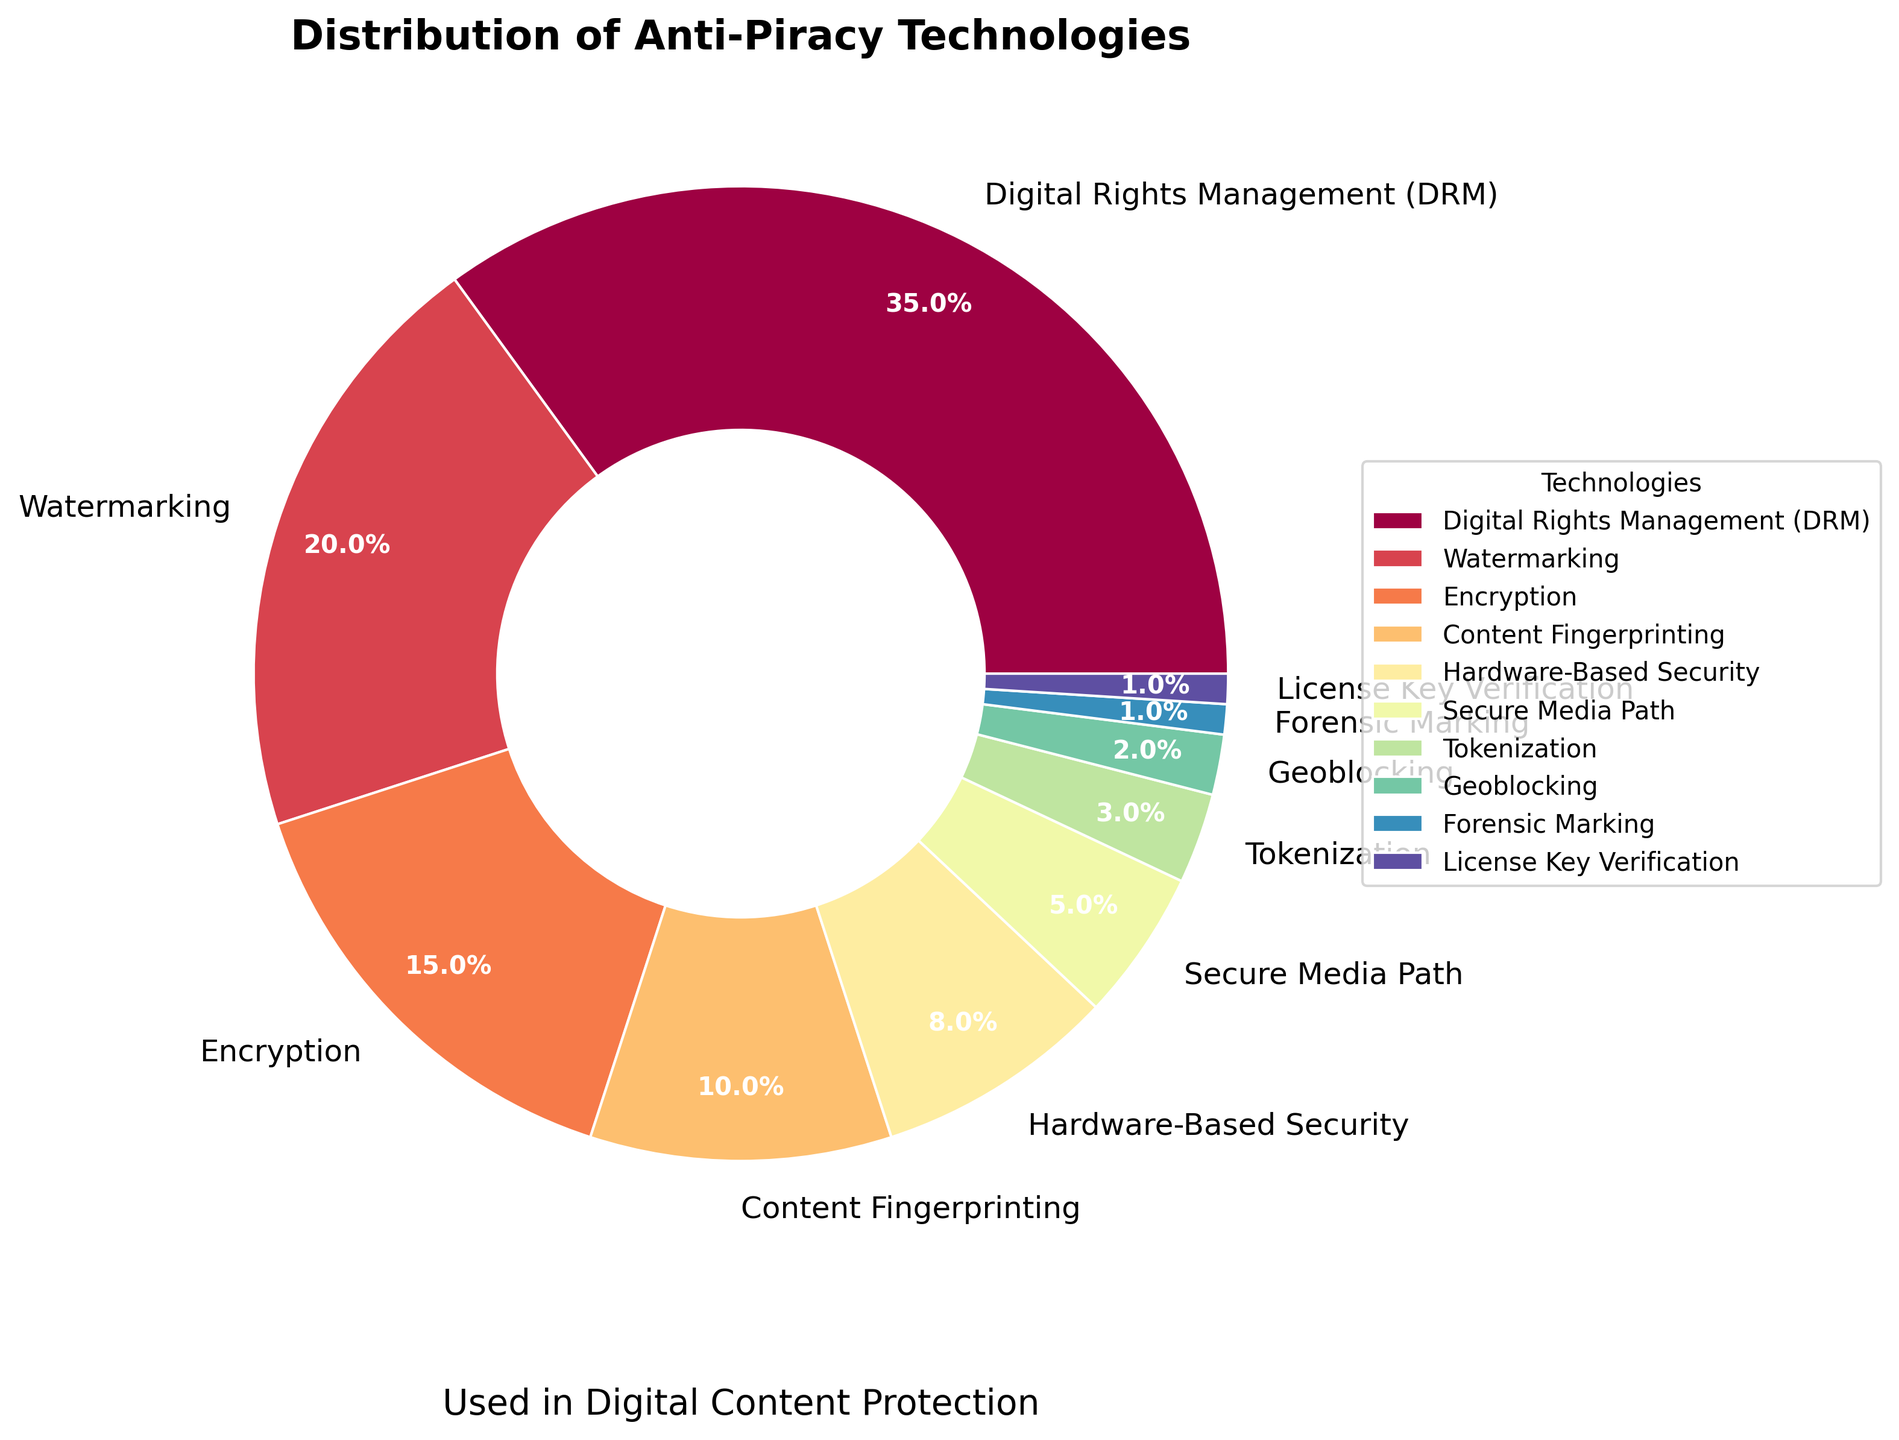What's the largest segment in the pie chart? The segment labeled "Digital Rights Management (DRM)" occupies the largest portion of the pie chart at 35%.
Answer: Digital Rights Management (DRM) Which two technologies have a combined percentage of 50%? The two technologies are "Digital Rights Management (DRM)" with 35% and "Watermarking" with 20%. Adding them gives 35% + 20% = 55%.
Answer: Digital Rights Management (DRM) and Watermarking How does Encryption compare to Content Fingerprinting in terms of percentage? Encryption makes up 15% of the pie chart, while Content Fingerprinting accounts for 10%. Therefore, Encryption has a higher percentage than Content Fingerprinting.
Answer: Encryption has a higher percentage Which technologies make up less than 5% of the pie chart combined? Technologies like "Tokenization" (3%), "Geoblocking" (2%), "Forensic Marking" (1%), and "License Key Verification" (1%) are each less than 5%. Summing these small segments: 3% + 2% + 1% + 1% = 7%.
Answer: Tokenization, Geoblocking, Forensic Marking, License Key Verification What is the total percentage of the three least represented technologies? The three least represented technologies are "Forensic Marking" (1%), "License Key Verification" (1%), and "Geoblocking" (2%). Adding these gives 1% + 1% + 2% = 4%.
Answer: 4% Which segment is larger, Hardware-Based Security or Secure Media Path? By how much? Hardware-Based Security accounts for 8% while Secure Media Path makes up 5%. The difference is 8% - 5% = 3%.
Answer: Hardware-Based Security by 3% What portion of the pie chart is represented by Watermarking and Encryption combined? Watermarking represents 20% and Encryption represents 15%. Adding these, the total portion is 20% + 15% = 35%.
Answer: 35% What is the average percentage of Digital Rights Management (DRM), Watermarking, and Encryption? Sum the percentages for DRM (35%), Watermarking (20%), and Encryption (15%): 35% + 20% + 15% = 70%. Divide by the number of technologies (3): 70% / 3 = 23.33%.
Answer: 23.33% What percentage is represented by technologies other than Digital Rights Management (DRM)? Subtract the percentage of DRM (35%) from the total (100%): 100% - 35% = 65%.
Answer: 65% 